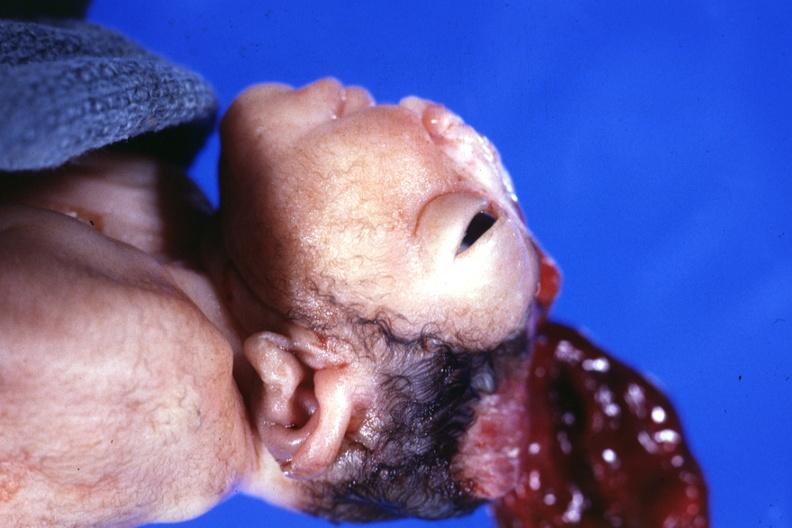what is present?
Answer the question using a single word or phrase. Anencephaly 